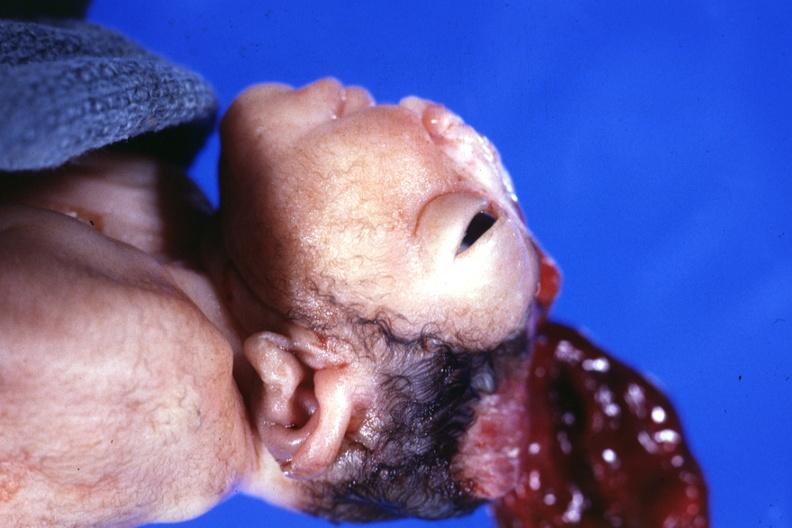what is present?
Answer the question using a single word or phrase. Anencephaly 